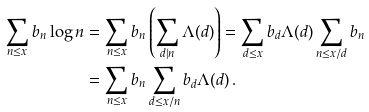Convert formula to latex. <formula><loc_0><loc_0><loc_500><loc_500>\sum _ { n \leq x } b _ { n } \log n & = \sum _ { n \leq x } b _ { n } \left ( \sum _ { d | n } \Lambda ( d ) \right ) = \sum _ { d \leq x } b _ { d } \Lambda ( d ) \sum _ { n \leq x / d } b _ { n } \\ & = \sum _ { n \leq x } b _ { n } \sum _ { d \leq x / n } b _ { d } \Lambda ( d ) \, .</formula> 